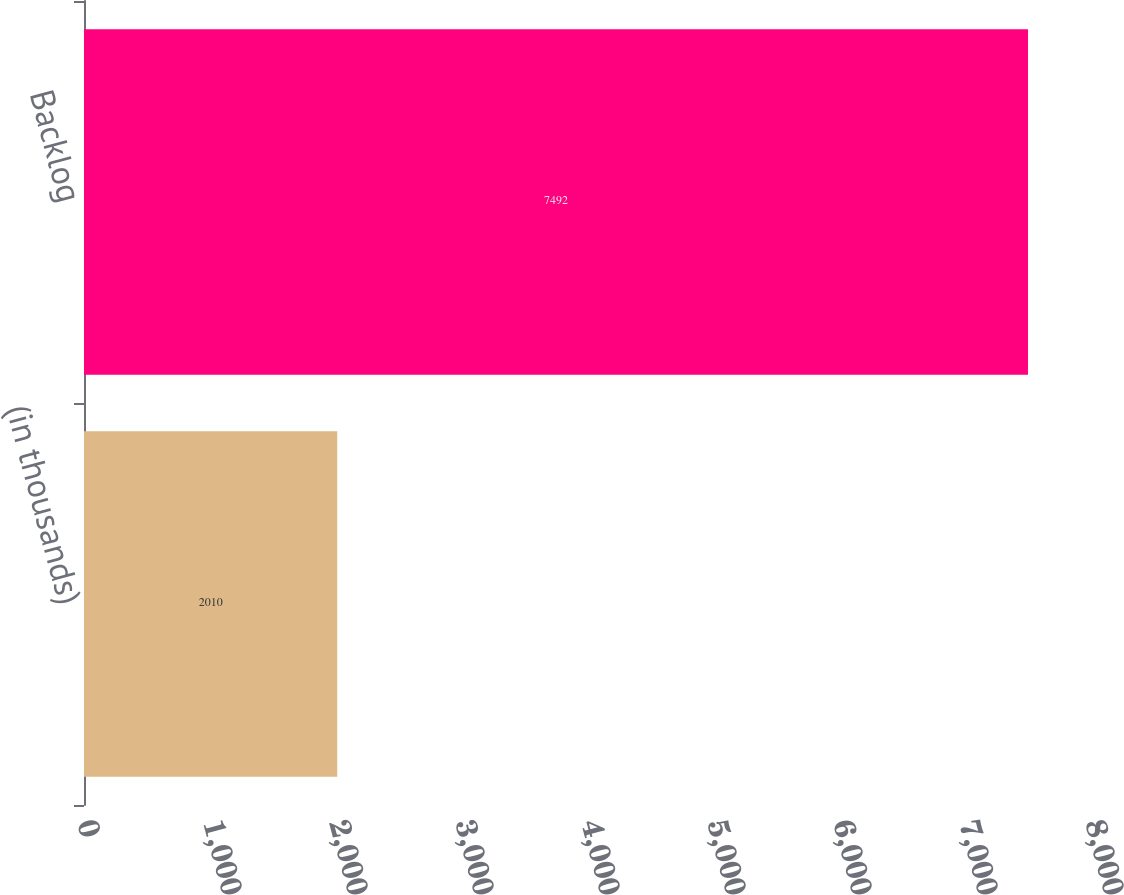<chart> <loc_0><loc_0><loc_500><loc_500><bar_chart><fcel>(in thousands)<fcel>Backlog<nl><fcel>2010<fcel>7492<nl></chart> 